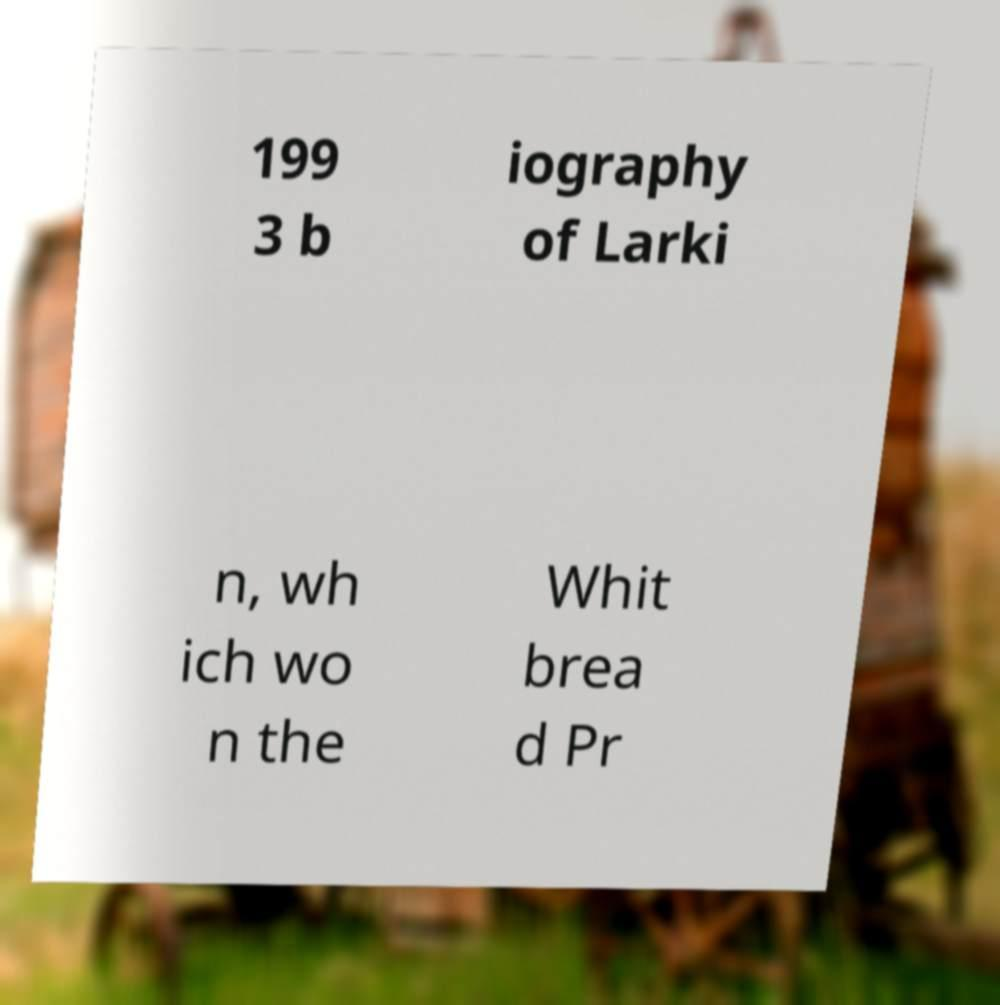Could you extract and type out the text from this image? 199 3 b iography of Larki n, wh ich wo n the Whit brea d Pr 